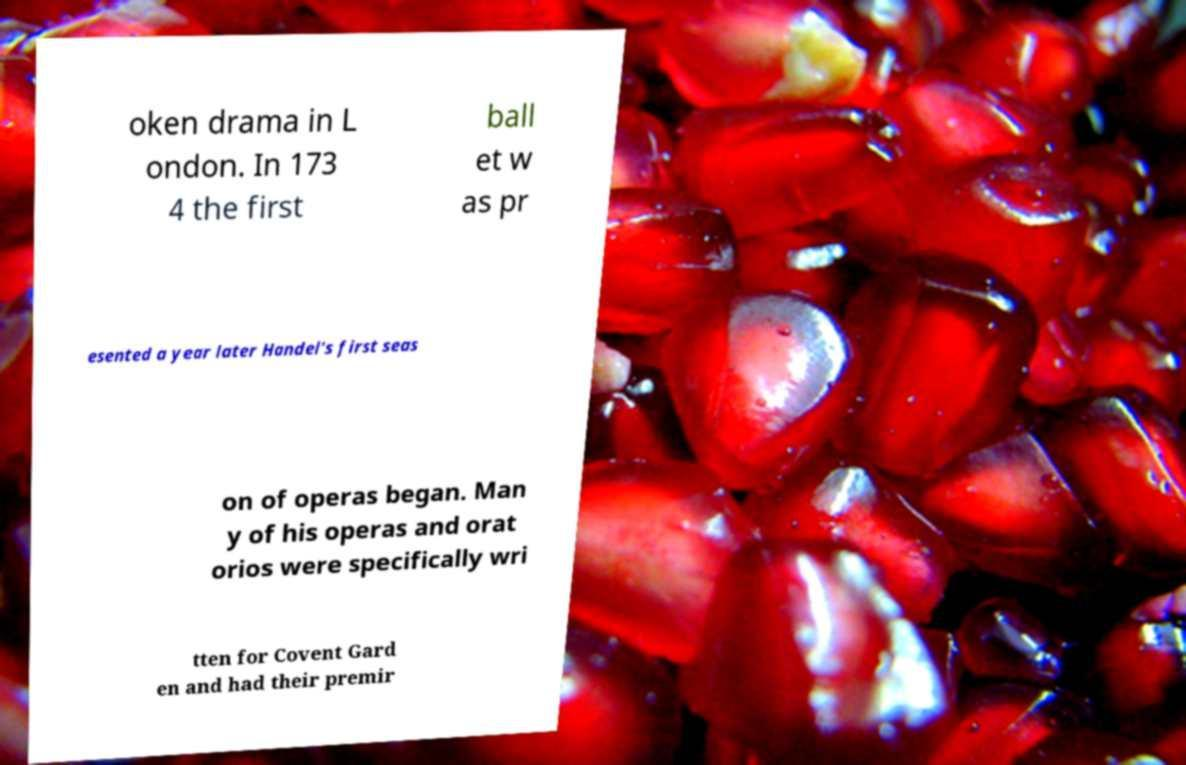There's text embedded in this image that I need extracted. Can you transcribe it verbatim? oken drama in L ondon. In 173 4 the first ball et w as pr esented a year later Handel's first seas on of operas began. Man y of his operas and orat orios were specifically wri tten for Covent Gard en and had their premir 